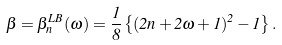<formula> <loc_0><loc_0><loc_500><loc_500>\beta = \beta _ { n } ^ { L B } ( \omega ) = \frac { 1 } { 8 } \left \{ ( 2 n + 2 \omega + 1 ) ^ { 2 } - 1 \right \} .</formula> 